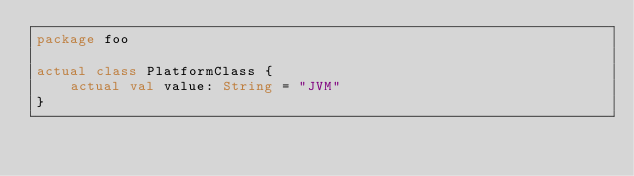<code> <loc_0><loc_0><loc_500><loc_500><_Kotlin_>package foo

actual class PlatformClass {
    actual val value: String = "JVM"
}</code> 